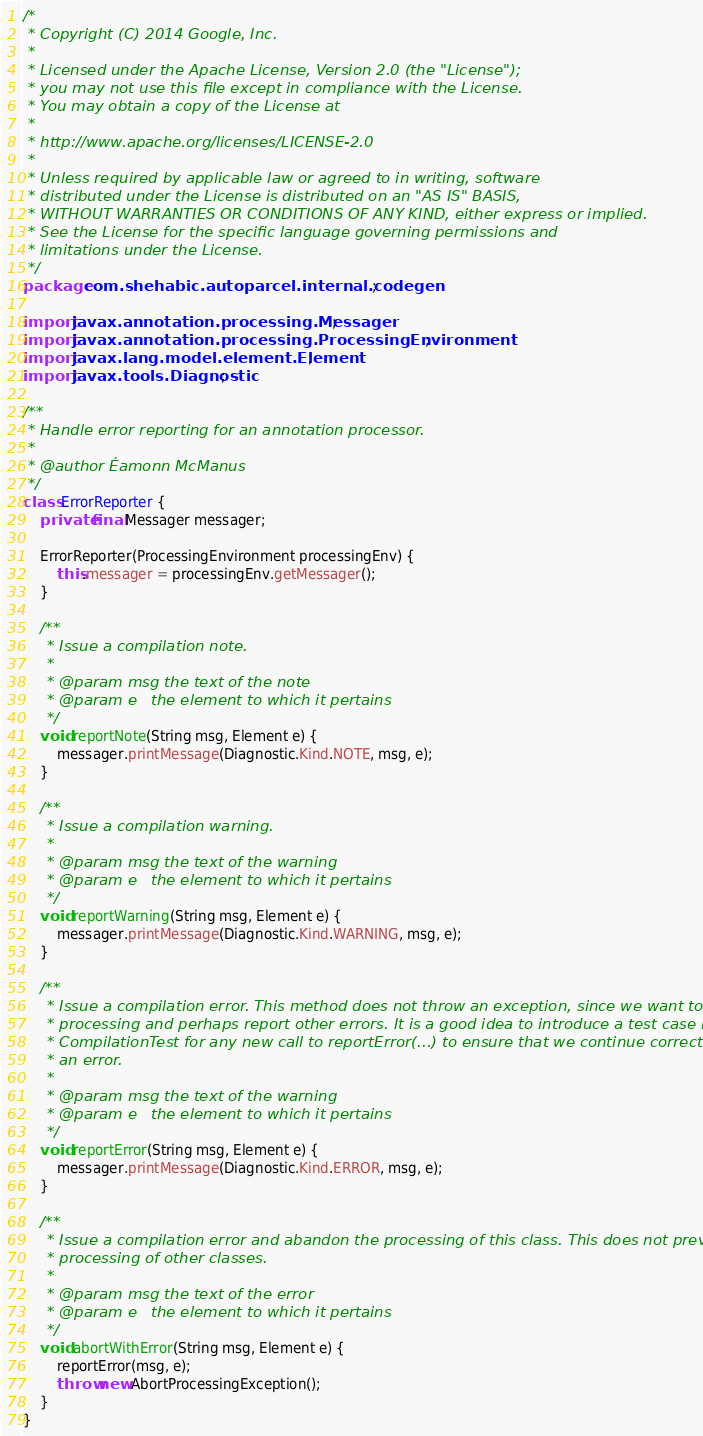Convert code to text. <code><loc_0><loc_0><loc_500><loc_500><_Java_>/*
 * Copyright (C) 2014 Google, Inc.
 *
 * Licensed under the Apache License, Version 2.0 (the "License");
 * you may not use this file except in compliance with the License.
 * You may obtain a copy of the License at
 *
 * http://www.apache.org/licenses/LICENSE-2.0
 *
 * Unless required by applicable law or agreed to in writing, software
 * distributed under the License is distributed on an "AS IS" BASIS,
 * WITHOUT WARRANTIES OR CONDITIONS OF ANY KIND, either express or implied.
 * See the License for the specific language governing permissions and
 * limitations under the License.
 */
package com.shehabic.autoparcel.internal.codegen;

import javax.annotation.processing.Messager;
import javax.annotation.processing.ProcessingEnvironment;
import javax.lang.model.element.Element;
import javax.tools.Diagnostic;

/**
 * Handle error reporting for an annotation processor.
 *
 * @author Éamonn McManus
 */
class ErrorReporter {
    private final Messager messager;

    ErrorReporter(ProcessingEnvironment processingEnv) {
        this.messager = processingEnv.getMessager();
    }

    /**
     * Issue a compilation note.
     *
     * @param msg the text of the note
     * @param e   the element to which it pertains
     */
    void reportNote(String msg, Element e) {
        messager.printMessage(Diagnostic.Kind.NOTE, msg, e);
    }

    /**
     * Issue a compilation warning.
     *
     * @param msg the text of the warning
     * @param e   the element to which it pertains
     */
    void reportWarning(String msg, Element e) {
        messager.printMessage(Diagnostic.Kind.WARNING, msg, e);
    }

    /**
     * Issue a compilation error. This method does not throw an exception, since we want to continue
     * processing and perhaps report other errors. It is a good idea to introduce a test case in
     * CompilationTest for any new call to reportError(...) to ensure that we continue correctly after
     * an error.
     *
     * @param msg the text of the warning
     * @param e   the element to which it pertains
     */
    void reportError(String msg, Element e) {
        messager.printMessage(Diagnostic.Kind.ERROR, msg, e);
    }

    /**
     * Issue a compilation error and abandon the processing of this class. This does not prevent the
     * processing of other classes.
     *
     * @param msg the text of the error
     * @param e   the element to which it pertains
     */
    void abortWithError(String msg, Element e) {
        reportError(msg, e);
        throw new AbortProcessingException();
    }
}</code> 